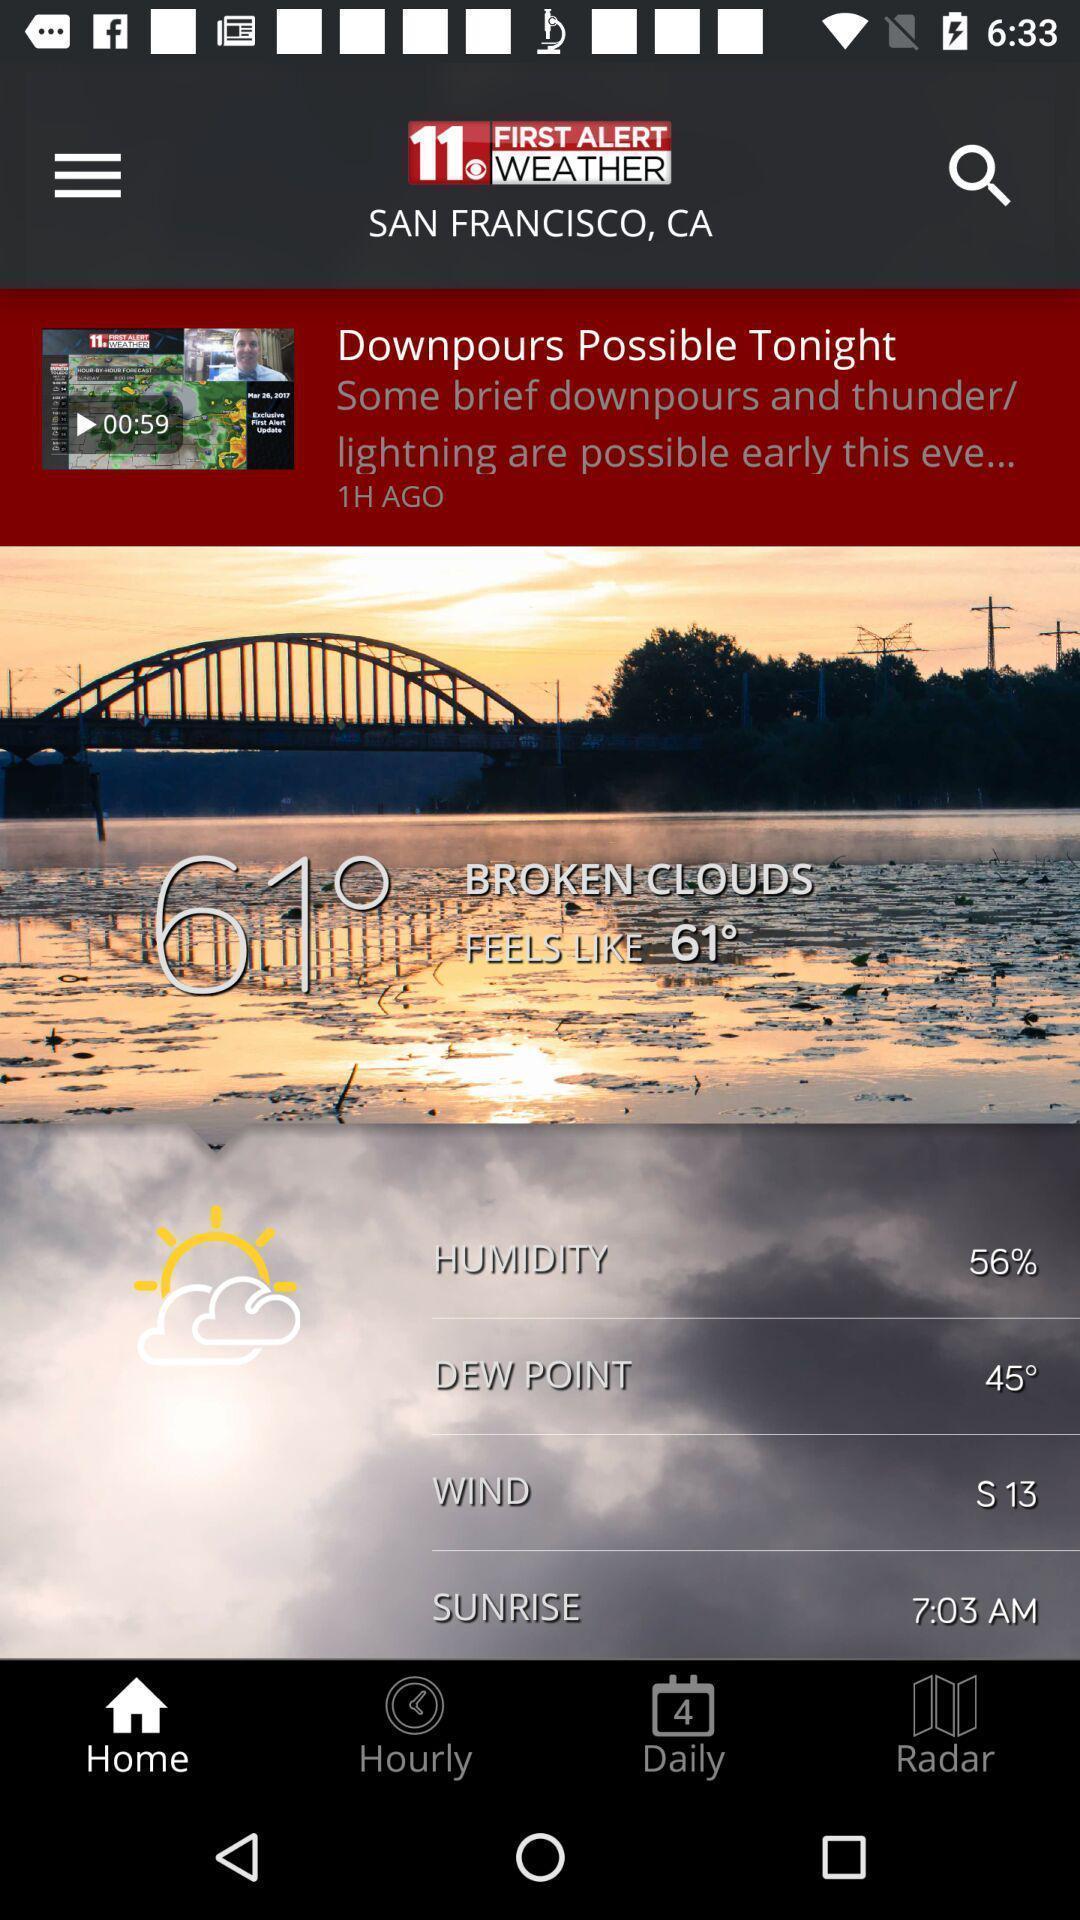What can you discern from this picture? Page showing information from a meteorology app. 